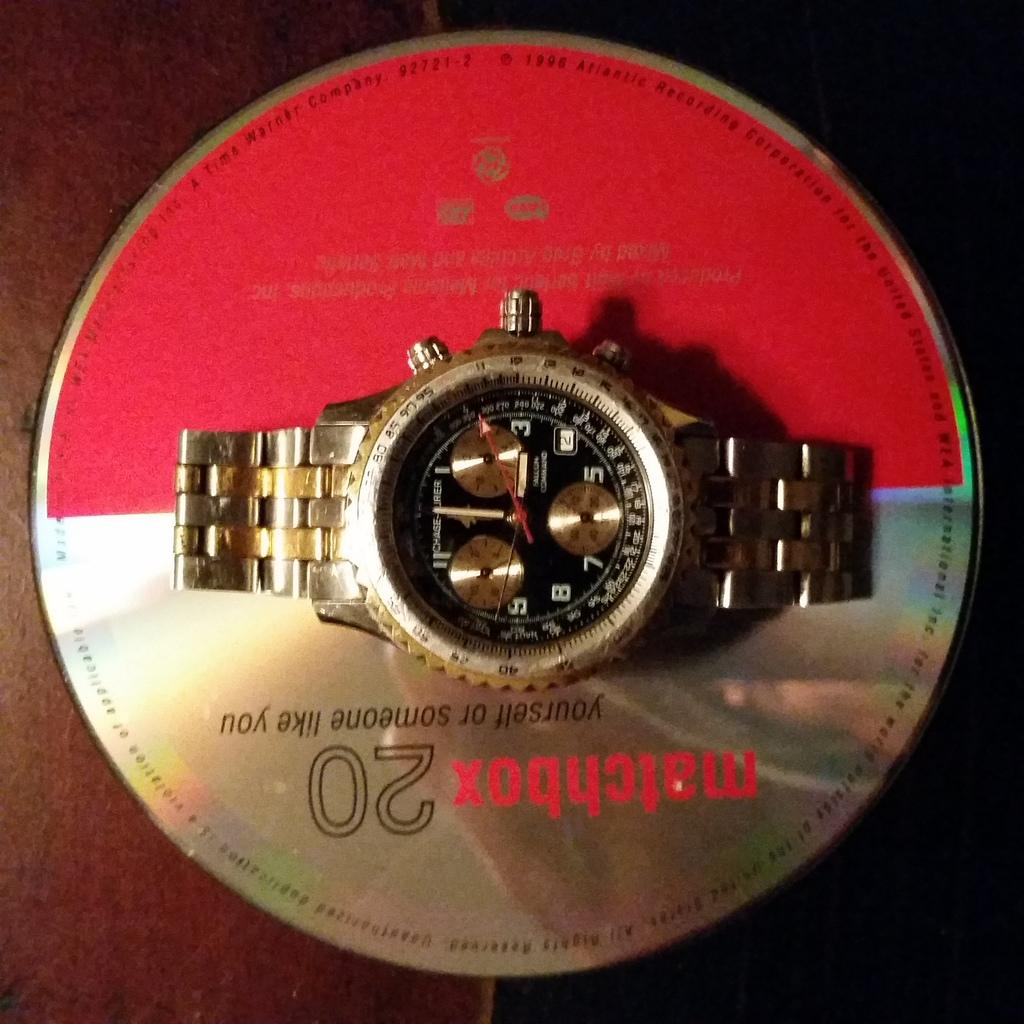Provide a one-sentence caption for the provided image. Compact disc that is upside down with a watch on top of it. 